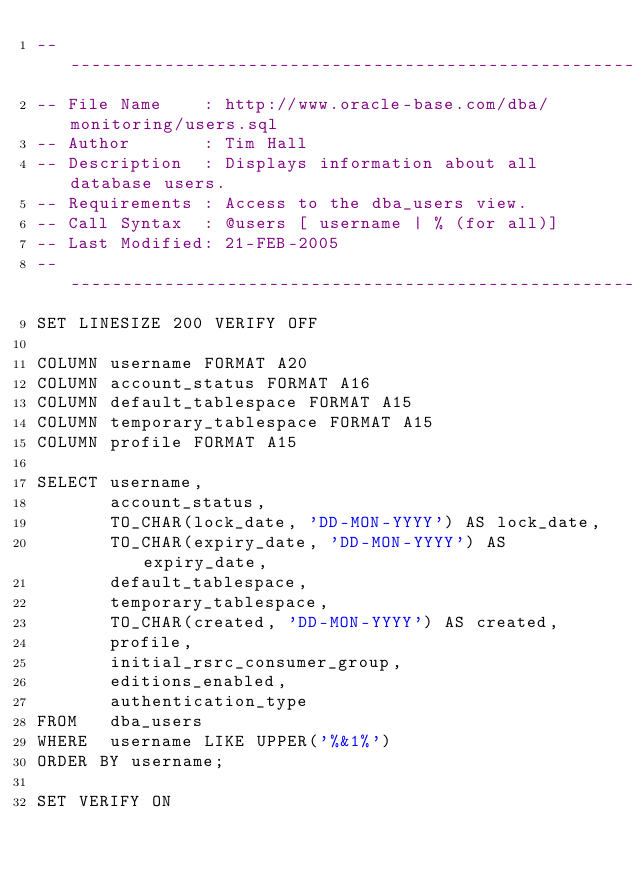Convert code to text. <code><loc_0><loc_0><loc_500><loc_500><_SQL_>-- -----------------------------------------------------------------------------------
-- File Name    : http://www.oracle-base.com/dba/monitoring/users.sql
-- Author       : Tim Hall
-- Description  : Displays information about all database users.
-- Requirements : Access to the dba_users view.
-- Call Syntax  : @users [ username | % (for all)]
-- Last Modified: 21-FEB-2005
-- -----------------------------------------------------------------------------------
SET LINESIZE 200 VERIFY OFF

COLUMN username FORMAT A20
COLUMN account_status FORMAT A16
COLUMN default_tablespace FORMAT A15
COLUMN temporary_tablespace FORMAT A15
COLUMN profile FORMAT A15

SELECT username,
       account_status,
       TO_CHAR(lock_date, 'DD-MON-YYYY') AS lock_date,
       TO_CHAR(expiry_date, 'DD-MON-YYYY') AS expiry_date,
       default_tablespace,
       temporary_tablespace,
       TO_CHAR(created, 'DD-MON-YYYY') AS created,
       profile,
       initial_rsrc_consumer_group,
       editions_enabled,
       authentication_type
FROM   dba_users
WHERE  username LIKE UPPER('%&1%')
ORDER BY username;

SET VERIFY ON</code> 